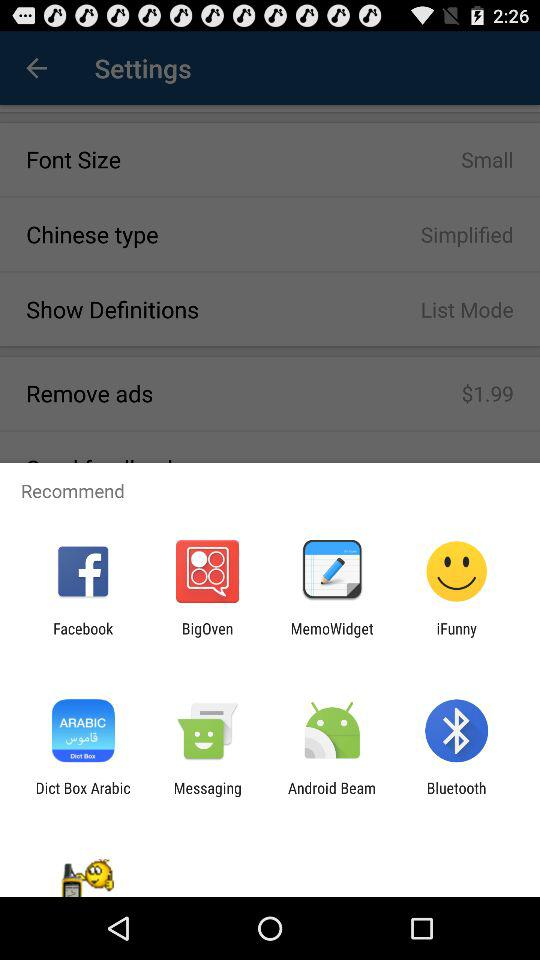Which are the different recommended options? The different recommended options are "Facebook", "BigOven", "MemoWidget", "iFunny", "Dict Box Arabic", "Messaging", "Android Beam" and "Bluetooth". 